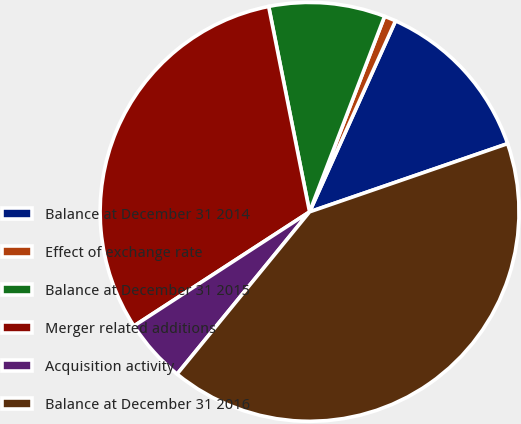Convert chart. <chart><loc_0><loc_0><loc_500><loc_500><pie_chart><fcel>Balance at December 31 2014<fcel>Effect of exchange rate<fcel>Balance at December 31 2015<fcel>Merger related additions<fcel>Acquisition activity<fcel>Balance at December 31 2016<nl><fcel>12.99%<fcel>0.9%<fcel>8.96%<fcel>31.04%<fcel>4.93%<fcel>41.18%<nl></chart> 